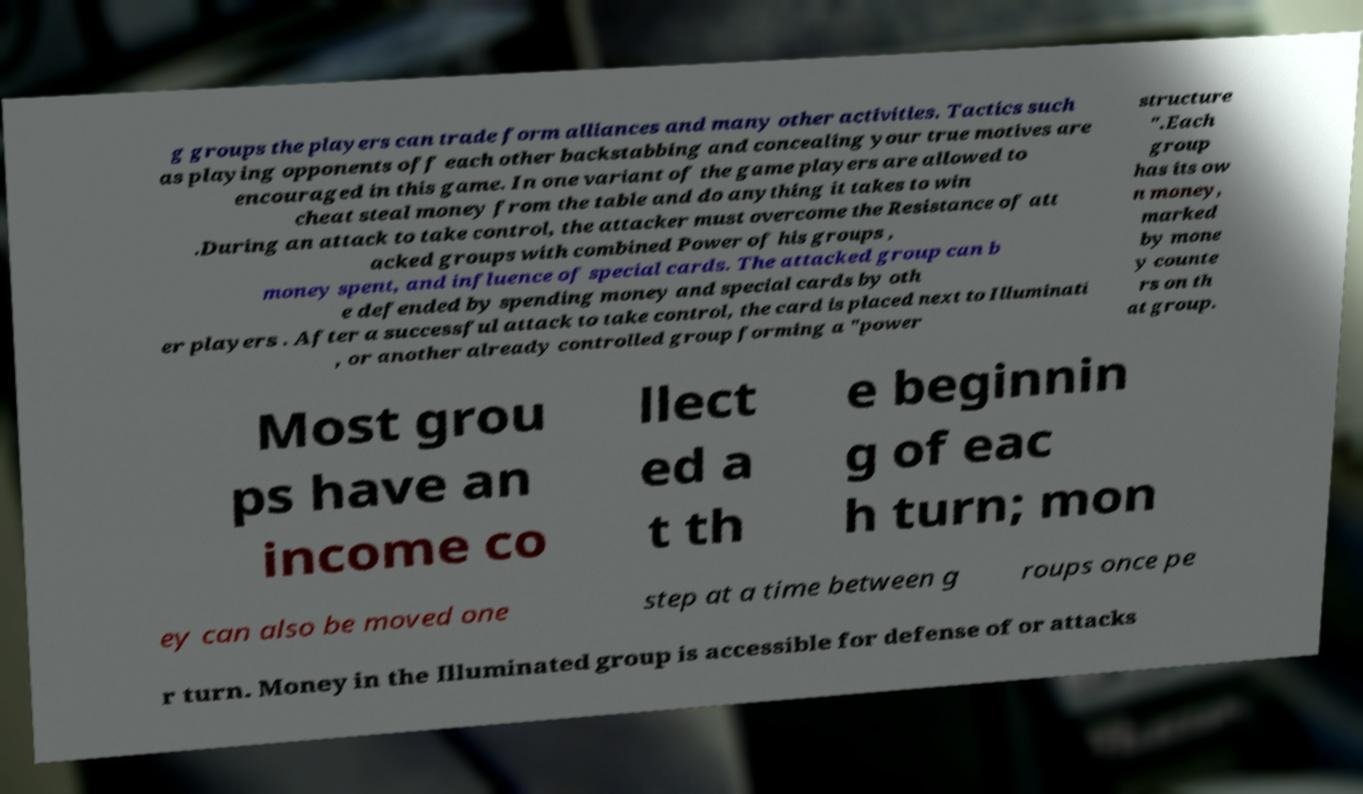Could you extract and type out the text from this image? g groups the players can trade form alliances and many other activities. Tactics such as playing opponents off each other backstabbing and concealing your true motives are encouraged in this game. In one variant of the game players are allowed to cheat steal money from the table and do anything it takes to win .During an attack to take control, the attacker must overcome the Resistance of att acked groups with combined Power of his groups , money spent, and influence of special cards. The attacked group can b e defended by spending money and special cards by oth er players . After a successful attack to take control, the card is placed next to Illuminati , or another already controlled group forming a "power structure ".Each group has its ow n money, marked by mone y counte rs on th at group. Most grou ps have an income co llect ed a t th e beginnin g of eac h turn; mon ey can also be moved one step at a time between g roups once pe r turn. Money in the Illuminated group is accessible for defense of or attacks 